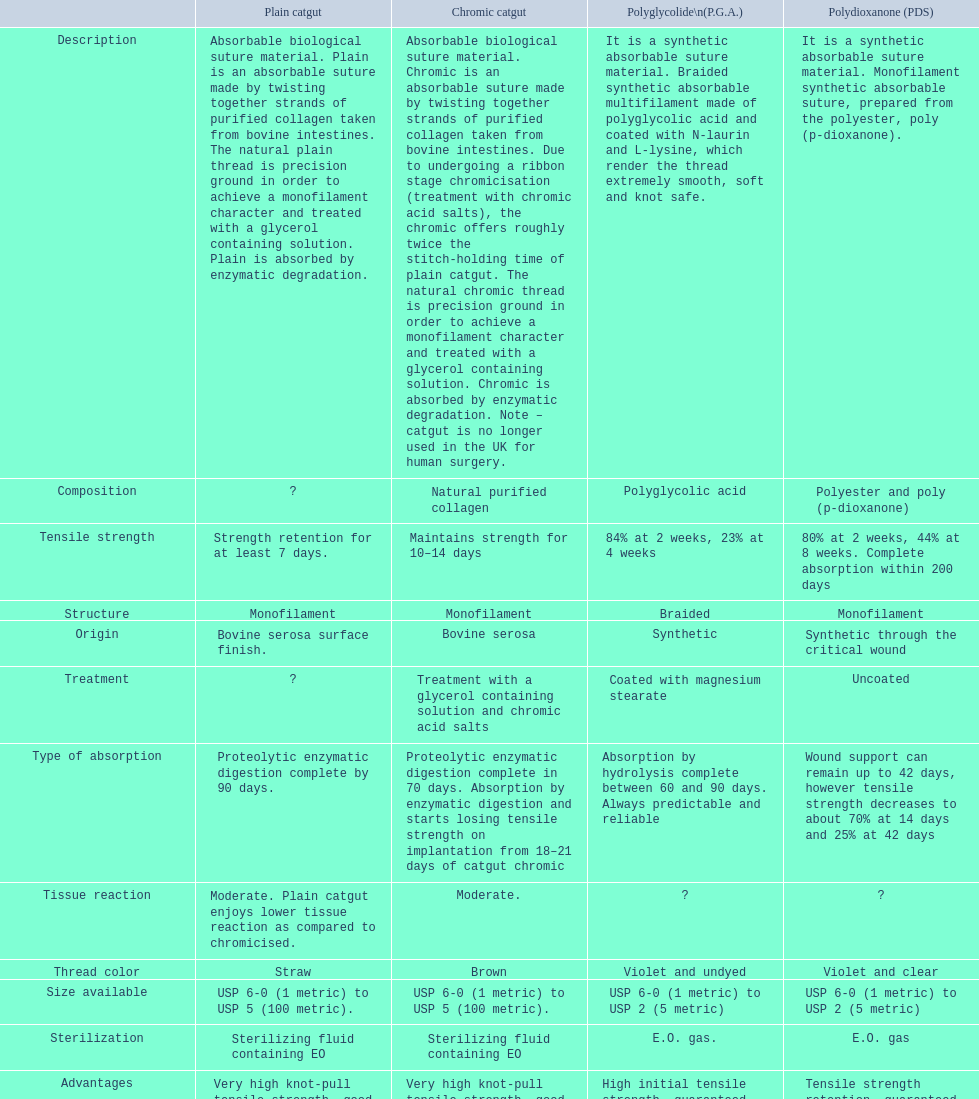How long does a chromic catgut maintain it's strength for 10-14 days. 